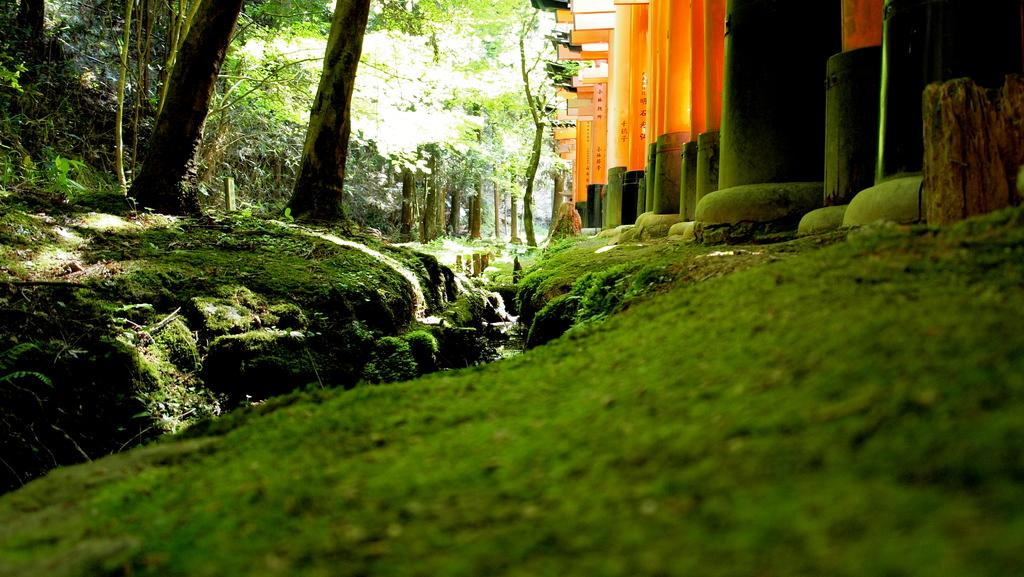What type of vegetation is at the bottom of the image? There is grass at the bottom of the image. What architectural feature can be seen on the right side of the image? There are pillars on the right side of the image. What type of natural element is on the left side of the image? There are trees on the left side of the image. What type of beast can be seen roaming in the grass in the image? There is no beast present in the image; it only features grass, pillars, and trees. What season is depicted in the image, given the presence of spring flowers? The image does not show any flowers or specific seasonal elements, so it cannot be determined that it is spring. 